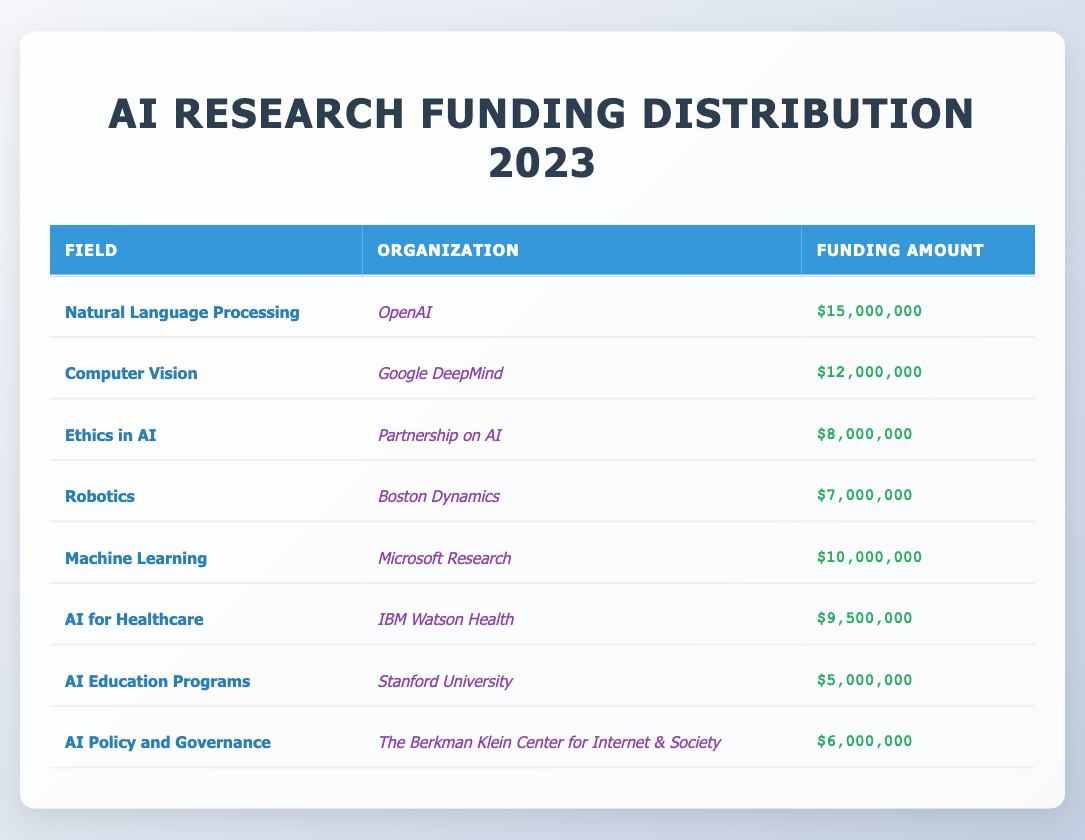What is the highest funding amount and which organization received it? The highest funding amount in the table is $15,000,000, which was received by OpenAI for the field of Natural Language Processing.
Answer: $15,000,000, OpenAI Which organization received funding for AI Ethics? Partnership on AI is the organization that received funding for Ethics in AI, amounting to $8,000,000.
Answer: Partnership on AI Calculating the total funding for fields related to education (AI Education Programs), how much was allocated? Only AI Education Programs listed one funding amount of $5,000,000, which is the total allocated for this field as there are no other related fields in the table.
Answer: $5,000,000 What was the total funding amount for all projects listed in the table? Adding all the funding amounts: 15,000,000 + 12,000,000 + 8,000,000 + 7,000,000 + 10,000,000 + 9,500,000 + 5,000,000 + 6,000,000 = 67,500,000, this is the total funding amount for all projects.
Answer: $67,500,000 Is it true that the total funding for AI for Healthcare and Robotics exceeds the total for Ethics in AI? The total for AI for Healthcare is $9,500,000 and for Robotics it is $7,000,000, so together they amount to $16,500,000. Ethics in AI amounts to $8,000,000. Since $16,500,000 is greater than $8,000,000, the statement is true.
Answer: Yes Which field received less funding, Computer Vision or Machine Learning? Computer Vision received $12,000,000 while Machine Learning received $10,000,000. Since $10,000,000 is less than $12,000,000, Machine Learning received less funding.
Answer: Machine Learning What is the average funding amount across all fields listed? The average funding amount is calculated by summing all amounts (67,500,000) and dividing by the number of fields (8). So, 67,500,000 / 8 = 8,437,500.
Answer: $8,437,500 Did any organization receive funding that is below $6 million? Only Stanford University received funding of $5,000,000 for AI Education Programs, which is below $6 million, therefore the answer is yes.
Answer: Yes 